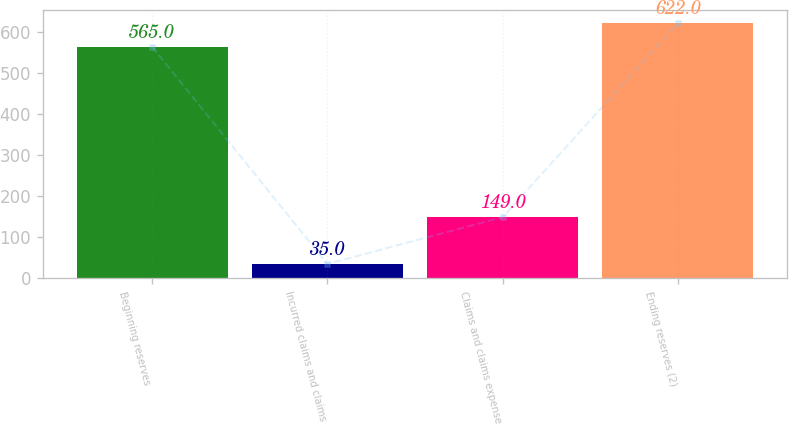Convert chart to OTSL. <chart><loc_0><loc_0><loc_500><loc_500><bar_chart><fcel>Beginning reserves<fcel>Incurred claims and claims<fcel>Claims and claims expense<fcel>Ending reserves (2)<nl><fcel>565<fcel>35<fcel>149<fcel>622<nl></chart> 